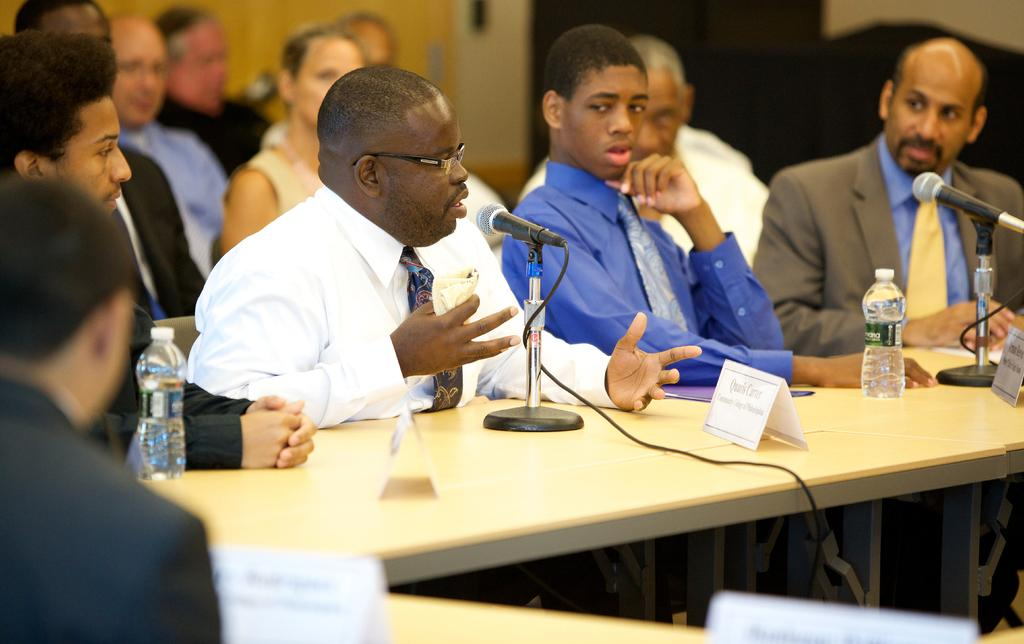What are the persons in the image doing? The persons in the image are sitting on chairs. What objects are placed in front of the chairs? Tables are placed in front of the chairs. What can be seen on the tables? There are name plates, disposable bottles, mics, and electric cables present on the tables. What type of coal is being used to make the paste in the image? There is no coal or paste present in the image. 